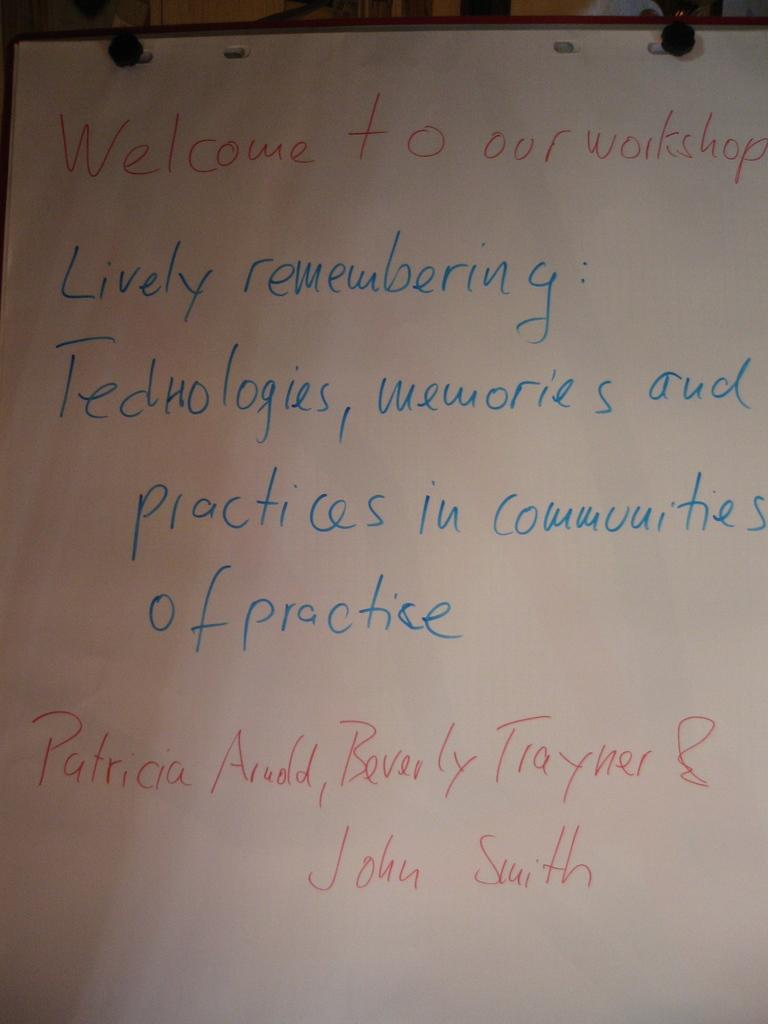<image>
Give a short and clear explanation of the subsequent image. the word memories is on the white piece of paper 